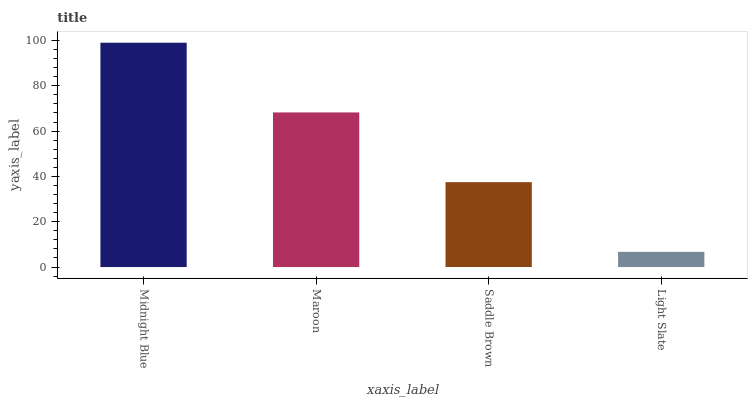Is Light Slate the minimum?
Answer yes or no. Yes. Is Midnight Blue the maximum?
Answer yes or no. Yes. Is Maroon the minimum?
Answer yes or no. No. Is Maroon the maximum?
Answer yes or no. No. Is Midnight Blue greater than Maroon?
Answer yes or no. Yes. Is Maroon less than Midnight Blue?
Answer yes or no. Yes. Is Maroon greater than Midnight Blue?
Answer yes or no. No. Is Midnight Blue less than Maroon?
Answer yes or no. No. Is Maroon the high median?
Answer yes or no. Yes. Is Saddle Brown the low median?
Answer yes or no. Yes. Is Saddle Brown the high median?
Answer yes or no. No. Is Light Slate the low median?
Answer yes or no. No. 